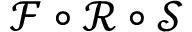Convert formula to latex. <formula><loc_0><loc_0><loc_500><loc_500>\mathcal { F } \circ \mathcal { R } \circ \mathcal { S }</formula> 